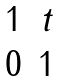<formula> <loc_0><loc_0><loc_500><loc_500>\begin{matrix} 1 & t \\ 0 & 1 \\ \end{matrix}</formula> 